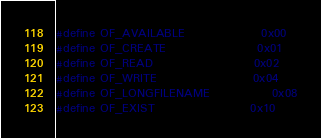Convert code to text. <code><loc_0><loc_0><loc_500><loc_500><_C_>#define OF_AVAILABLE                0x00
#define OF_CREATE                   0x01
#define OF_READ                     0x02
#define OF_WRITE                    0x04
#define OF_LONGFILENAME             0x08
#define OF_EXIST                    0x10
</code> 